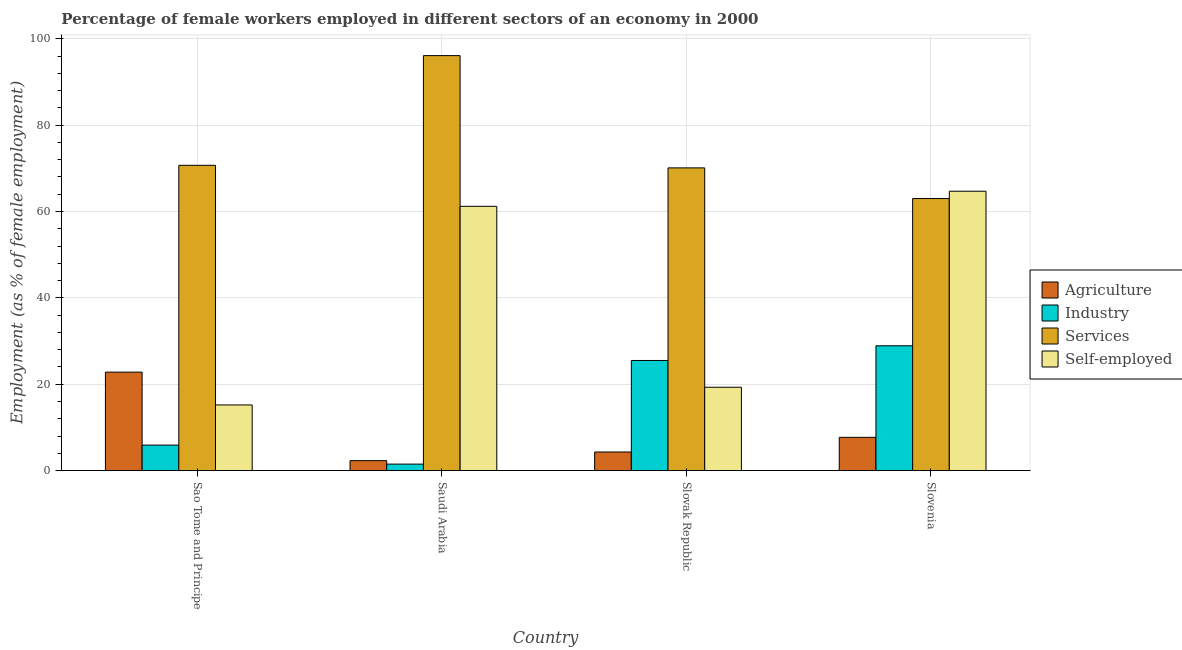How many different coloured bars are there?
Provide a short and direct response. 4. How many groups of bars are there?
Your answer should be compact. 4. Are the number of bars per tick equal to the number of legend labels?
Give a very brief answer. Yes. How many bars are there on the 3rd tick from the right?
Give a very brief answer. 4. What is the label of the 2nd group of bars from the left?
Provide a short and direct response. Saudi Arabia. In how many cases, is the number of bars for a given country not equal to the number of legend labels?
Offer a very short reply. 0. What is the percentage of female workers in agriculture in Sao Tome and Principe?
Provide a succinct answer. 22.8. Across all countries, what is the maximum percentage of female workers in agriculture?
Offer a terse response. 22.8. In which country was the percentage of female workers in agriculture maximum?
Your answer should be compact. Sao Tome and Principe. In which country was the percentage of female workers in agriculture minimum?
Your answer should be compact. Saudi Arabia. What is the total percentage of female workers in industry in the graph?
Provide a succinct answer. 61.8. What is the difference between the percentage of female workers in agriculture in Saudi Arabia and that in Slovenia?
Give a very brief answer. -5.4. What is the difference between the percentage of female workers in services in Slovak Republic and the percentage of female workers in industry in Saudi Arabia?
Give a very brief answer. 68.6. What is the average percentage of female workers in services per country?
Offer a very short reply. 74.97. What is the difference between the percentage of self employed female workers and percentage of female workers in agriculture in Slovenia?
Provide a short and direct response. 57. What is the ratio of the percentage of female workers in agriculture in Sao Tome and Principe to that in Slovenia?
Give a very brief answer. 2.96. Is the difference between the percentage of self employed female workers in Saudi Arabia and Slovenia greater than the difference between the percentage of female workers in industry in Saudi Arabia and Slovenia?
Give a very brief answer. Yes. What is the difference between the highest and the second highest percentage of female workers in industry?
Provide a short and direct response. 3.4. What is the difference between the highest and the lowest percentage of female workers in services?
Your answer should be compact. 33.1. What does the 3rd bar from the left in Slovak Republic represents?
Keep it short and to the point. Services. What does the 1st bar from the right in Slovenia represents?
Provide a succinct answer. Self-employed. Is it the case that in every country, the sum of the percentage of female workers in agriculture and percentage of female workers in industry is greater than the percentage of female workers in services?
Offer a very short reply. No. How many bars are there?
Offer a very short reply. 16. Are all the bars in the graph horizontal?
Your answer should be very brief. No. Where does the legend appear in the graph?
Your response must be concise. Center right. How are the legend labels stacked?
Give a very brief answer. Vertical. What is the title of the graph?
Offer a terse response. Percentage of female workers employed in different sectors of an economy in 2000. What is the label or title of the Y-axis?
Your response must be concise. Employment (as % of female employment). What is the Employment (as % of female employment) in Agriculture in Sao Tome and Principe?
Your response must be concise. 22.8. What is the Employment (as % of female employment) in Industry in Sao Tome and Principe?
Ensure brevity in your answer.  5.9. What is the Employment (as % of female employment) in Services in Sao Tome and Principe?
Offer a very short reply. 70.7. What is the Employment (as % of female employment) in Self-employed in Sao Tome and Principe?
Give a very brief answer. 15.2. What is the Employment (as % of female employment) in Agriculture in Saudi Arabia?
Offer a very short reply. 2.3. What is the Employment (as % of female employment) of Services in Saudi Arabia?
Your response must be concise. 96.1. What is the Employment (as % of female employment) of Self-employed in Saudi Arabia?
Provide a short and direct response. 61.2. What is the Employment (as % of female employment) of Agriculture in Slovak Republic?
Offer a very short reply. 4.3. What is the Employment (as % of female employment) of Industry in Slovak Republic?
Keep it short and to the point. 25.5. What is the Employment (as % of female employment) in Services in Slovak Republic?
Keep it short and to the point. 70.1. What is the Employment (as % of female employment) of Self-employed in Slovak Republic?
Provide a short and direct response. 19.3. What is the Employment (as % of female employment) in Agriculture in Slovenia?
Give a very brief answer. 7.7. What is the Employment (as % of female employment) in Industry in Slovenia?
Ensure brevity in your answer.  28.9. What is the Employment (as % of female employment) of Services in Slovenia?
Provide a short and direct response. 63. What is the Employment (as % of female employment) of Self-employed in Slovenia?
Your answer should be very brief. 64.7. Across all countries, what is the maximum Employment (as % of female employment) in Agriculture?
Ensure brevity in your answer.  22.8. Across all countries, what is the maximum Employment (as % of female employment) of Industry?
Ensure brevity in your answer.  28.9. Across all countries, what is the maximum Employment (as % of female employment) of Services?
Your answer should be very brief. 96.1. Across all countries, what is the maximum Employment (as % of female employment) of Self-employed?
Offer a very short reply. 64.7. Across all countries, what is the minimum Employment (as % of female employment) in Agriculture?
Your answer should be compact. 2.3. Across all countries, what is the minimum Employment (as % of female employment) in Industry?
Offer a very short reply. 1.5. Across all countries, what is the minimum Employment (as % of female employment) of Self-employed?
Your response must be concise. 15.2. What is the total Employment (as % of female employment) in Agriculture in the graph?
Your answer should be very brief. 37.1. What is the total Employment (as % of female employment) in Industry in the graph?
Ensure brevity in your answer.  61.8. What is the total Employment (as % of female employment) in Services in the graph?
Offer a terse response. 299.9. What is the total Employment (as % of female employment) in Self-employed in the graph?
Your answer should be compact. 160.4. What is the difference between the Employment (as % of female employment) in Agriculture in Sao Tome and Principe and that in Saudi Arabia?
Ensure brevity in your answer.  20.5. What is the difference between the Employment (as % of female employment) of Industry in Sao Tome and Principe and that in Saudi Arabia?
Ensure brevity in your answer.  4.4. What is the difference between the Employment (as % of female employment) in Services in Sao Tome and Principe and that in Saudi Arabia?
Keep it short and to the point. -25.4. What is the difference between the Employment (as % of female employment) of Self-employed in Sao Tome and Principe and that in Saudi Arabia?
Keep it short and to the point. -46. What is the difference between the Employment (as % of female employment) in Agriculture in Sao Tome and Principe and that in Slovak Republic?
Give a very brief answer. 18.5. What is the difference between the Employment (as % of female employment) of Industry in Sao Tome and Principe and that in Slovak Republic?
Ensure brevity in your answer.  -19.6. What is the difference between the Employment (as % of female employment) in Services in Sao Tome and Principe and that in Slovak Republic?
Make the answer very short. 0.6. What is the difference between the Employment (as % of female employment) of Agriculture in Sao Tome and Principe and that in Slovenia?
Ensure brevity in your answer.  15.1. What is the difference between the Employment (as % of female employment) of Services in Sao Tome and Principe and that in Slovenia?
Keep it short and to the point. 7.7. What is the difference between the Employment (as % of female employment) of Self-employed in Sao Tome and Principe and that in Slovenia?
Your answer should be compact. -49.5. What is the difference between the Employment (as % of female employment) in Agriculture in Saudi Arabia and that in Slovak Republic?
Give a very brief answer. -2. What is the difference between the Employment (as % of female employment) of Industry in Saudi Arabia and that in Slovak Republic?
Keep it short and to the point. -24. What is the difference between the Employment (as % of female employment) in Services in Saudi Arabia and that in Slovak Republic?
Your response must be concise. 26. What is the difference between the Employment (as % of female employment) in Self-employed in Saudi Arabia and that in Slovak Republic?
Offer a terse response. 41.9. What is the difference between the Employment (as % of female employment) in Industry in Saudi Arabia and that in Slovenia?
Your response must be concise. -27.4. What is the difference between the Employment (as % of female employment) in Services in Saudi Arabia and that in Slovenia?
Ensure brevity in your answer.  33.1. What is the difference between the Employment (as % of female employment) of Self-employed in Saudi Arabia and that in Slovenia?
Give a very brief answer. -3.5. What is the difference between the Employment (as % of female employment) in Agriculture in Slovak Republic and that in Slovenia?
Your answer should be compact. -3.4. What is the difference between the Employment (as % of female employment) in Industry in Slovak Republic and that in Slovenia?
Give a very brief answer. -3.4. What is the difference between the Employment (as % of female employment) of Services in Slovak Republic and that in Slovenia?
Offer a terse response. 7.1. What is the difference between the Employment (as % of female employment) in Self-employed in Slovak Republic and that in Slovenia?
Ensure brevity in your answer.  -45.4. What is the difference between the Employment (as % of female employment) in Agriculture in Sao Tome and Principe and the Employment (as % of female employment) in Industry in Saudi Arabia?
Your answer should be compact. 21.3. What is the difference between the Employment (as % of female employment) in Agriculture in Sao Tome and Principe and the Employment (as % of female employment) in Services in Saudi Arabia?
Make the answer very short. -73.3. What is the difference between the Employment (as % of female employment) of Agriculture in Sao Tome and Principe and the Employment (as % of female employment) of Self-employed in Saudi Arabia?
Provide a short and direct response. -38.4. What is the difference between the Employment (as % of female employment) in Industry in Sao Tome and Principe and the Employment (as % of female employment) in Services in Saudi Arabia?
Ensure brevity in your answer.  -90.2. What is the difference between the Employment (as % of female employment) of Industry in Sao Tome and Principe and the Employment (as % of female employment) of Self-employed in Saudi Arabia?
Make the answer very short. -55.3. What is the difference between the Employment (as % of female employment) of Agriculture in Sao Tome and Principe and the Employment (as % of female employment) of Industry in Slovak Republic?
Offer a very short reply. -2.7. What is the difference between the Employment (as % of female employment) of Agriculture in Sao Tome and Principe and the Employment (as % of female employment) of Services in Slovak Republic?
Give a very brief answer. -47.3. What is the difference between the Employment (as % of female employment) of Agriculture in Sao Tome and Principe and the Employment (as % of female employment) of Self-employed in Slovak Republic?
Offer a very short reply. 3.5. What is the difference between the Employment (as % of female employment) in Industry in Sao Tome and Principe and the Employment (as % of female employment) in Services in Slovak Republic?
Provide a succinct answer. -64.2. What is the difference between the Employment (as % of female employment) in Industry in Sao Tome and Principe and the Employment (as % of female employment) in Self-employed in Slovak Republic?
Ensure brevity in your answer.  -13.4. What is the difference between the Employment (as % of female employment) of Services in Sao Tome and Principe and the Employment (as % of female employment) of Self-employed in Slovak Republic?
Keep it short and to the point. 51.4. What is the difference between the Employment (as % of female employment) of Agriculture in Sao Tome and Principe and the Employment (as % of female employment) of Industry in Slovenia?
Your response must be concise. -6.1. What is the difference between the Employment (as % of female employment) of Agriculture in Sao Tome and Principe and the Employment (as % of female employment) of Services in Slovenia?
Provide a succinct answer. -40.2. What is the difference between the Employment (as % of female employment) of Agriculture in Sao Tome and Principe and the Employment (as % of female employment) of Self-employed in Slovenia?
Offer a very short reply. -41.9. What is the difference between the Employment (as % of female employment) of Industry in Sao Tome and Principe and the Employment (as % of female employment) of Services in Slovenia?
Your response must be concise. -57.1. What is the difference between the Employment (as % of female employment) in Industry in Sao Tome and Principe and the Employment (as % of female employment) in Self-employed in Slovenia?
Your answer should be compact. -58.8. What is the difference between the Employment (as % of female employment) of Agriculture in Saudi Arabia and the Employment (as % of female employment) of Industry in Slovak Republic?
Your answer should be very brief. -23.2. What is the difference between the Employment (as % of female employment) of Agriculture in Saudi Arabia and the Employment (as % of female employment) of Services in Slovak Republic?
Ensure brevity in your answer.  -67.8. What is the difference between the Employment (as % of female employment) of Agriculture in Saudi Arabia and the Employment (as % of female employment) of Self-employed in Slovak Republic?
Your answer should be very brief. -17. What is the difference between the Employment (as % of female employment) of Industry in Saudi Arabia and the Employment (as % of female employment) of Services in Slovak Republic?
Make the answer very short. -68.6. What is the difference between the Employment (as % of female employment) of Industry in Saudi Arabia and the Employment (as % of female employment) of Self-employed in Slovak Republic?
Ensure brevity in your answer.  -17.8. What is the difference between the Employment (as % of female employment) of Services in Saudi Arabia and the Employment (as % of female employment) of Self-employed in Slovak Republic?
Give a very brief answer. 76.8. What is the difference between the Employment (as % of female employment) of Agriculture in Saudi Arabia and the Employment (as % of female employment) of Industry in Slovenia?
Your answer should be compact. -26.6. What is the difference between the Employment (as % of female employment) in Agriculture in Saudi Arabia and the Employment (as % of female employment) in Services in Slovenia?
Provide a short and direct response. -60.7. What is the difference between the Employment (as % of female employment) of Agriculture in Saudi Arabia and the Employment (as % of female employment) of Self-employed in Slovenia?
Keep it short and to the point. -62.4. What is the difference between the Employment (as % of female employment) in Industry in Saudi Arabia and the Employment (as % of female employment) in Services in Slovenia?
Offer a very short reply. -61.5. What is the difference between the Employment (as % of female employment) of Industry in Saudi Arabia and the Employment (as % of female employment) of Self-employed in Slovenia?
Make the answer very short. -63.2. What is the difference between the Employment (as % of female employment) in Services in Saudi Arabia and the Employment (as % of female employment) in Self-employed in Slovenia?
Ensure brevity in your answer.  31.4. What is the difference between the Employment (as % of female employment) of Agriculture in Slovak Republic and the Employment (as % of female employment) of Industry in Slovenia?
Give a very brief answer. -24.6. What is the difference between the Employment (as % of female employment) of Agriculture in Slovak Republic and the Employment (as % of female employment) of Services in Slovenia?
Your answer should be very brief. -58.7. What is the difference between the Employment (as % of female employment) in Agriculture in Slovak Republic and the Employment (as % of female employment) in Self-employed in Slovenia?
Offer a terse response. -60.4. What is the difference between the Employment (as % of female employment) of Industry in Slovak Republic and the Employment (as % of female employment) of Services in Slovenia?
Provide a succinct answer. -37.5. What is the difference between the Employment (as % of female employment) in Industry in Slovak Republic and the Employment (as % of female employment) in Self-employed in Slovenia?
Your answer should be very brief. -39.2. What is the average Employment (as % of female employment) in Agriculture per country?
Your answer should be compact. 9.28. What is the average Employment (as % of female employment) in Industry per country?
Your answer should be compact. 15.45. What is the average Employment (as % of female employment) in Services per country?
Provide a succinct answer. 74.97. What is the average Employment (as % of female employment) in Self-employed per country?
Your answer should be compact. 40.1. What is the difference between the Employment (as % of female employment) of Agriculture and Employment (as % of female employment) of Services in Sao Tome and Principe?
Provide a succinct answer. -47.9. What is the difference between the Employment (as % of female employment) of Agriculture and Employment (as % of female employment) of Self-employed in Sao Tome and Principe?
Your response must be concise. 7.6. What is the difference between the Employment (as % of female employment) in Industry and Employment (as % of female employment) in Services in Sao Tome and Principe?
Offer a very short reply. -64.8. What is the difference between the Employment (as % of female employment) of Industry and Employment (as % of female employment) of Self-employed in Sao Tome and Principe?
Ensure brevity in your answer.  -9.3. What is the difference between the Employment (as % of female employment) of Services and Employment (as % of female employment) of Self-employed in Sao Tome and Principe?
Keep it short and to the point. 55.5. What is the difference between the Employment (as % of female employment) of Agriculture and Employment (as % of female employment) of Industry in Saudi Arabia?
Provide a succinct answer. 0.8. What is the difference between the Employment (as % of female employment) in Agriculture and Employment (as % of female employment) in Services in Saudi Arabia?
Give a very brief answer. -93.8. What is the difference between the Employment (as % of female employment) in Agriculture and Employment (as % of female employment) in Self-employed in Saudi Arabia?
Offer a terse response. -58.9. What is the difference between the Employment (as % of female employment) in Industry and Employment (as % of female employment) in Services in Saudi Arabia?
Offer a very short reply. -94.6. What is the difference between the Employment (as % of female employment) of Industry and Employment (as % of female employment) of Self-employed in Saudi Arabia?
Make the answer very short. -59.7. What is the difference between the Employment (as % of female employment) of Services and Employment (as % of female employment) of Self-employed in Saudi Arabia?
Your answer should be very brief. 34.9. What is the difference between the Employment (as % of female employment) of Agriculture and Employment (as % of female employment) of Industry in Slovak Republic?
Your answer should be compact. -21.2. What is the difference between the Employment (as % of female employment) in Agriculture and Employment (as % of female employment) in Services in Slovak Republic?
Give a very brief answer. -65.8. What is the difference between the Employment (as % of female employment) of Industry and Employment (as % of female employment) of Services in Slovak Republic?
Give a very brief answer. -44.6. What is the difference between the Employment (as % of female employment) of Industry and Employment (as % of female employment) of Self-employed in Slovak Republic?
Offer a very short reply. 6.2. What is the difference between the Employment (as % of female employment) of Services and Employment (as % of female employment) of Self-employed in Slovak Republic?
Offer a terse response. 50.8. What is the difference between the Employment (as % of female employment) in Agriculture and Employment (as % of female employment) in Industry in Slovenia?
Offer a very short reply. -21.2. What is the difference between the Employment (as % of female employment) of Agriculture and Employment (as % of female employment) of Services in Slovenia?
Your answer should be very brief. -55.3. What is the difference between the Employment (as % of female employment) in Agriculture and Employment (as % of female employment) in Self-employed in Slovenia?
Make the answer very short. -57. What is the difference between the Employment (as % of female employment) of Industry and Employment (as % of female employment) of Services in Slovenia?
Make the answer very short. -34.1. What is the difference between the Employment (as % of female employment) of Industry and Employment (as % of female employment) of Self-employed in Slovenia?
Your response must be concise. -35.8. What is the difference between the Employment (as % of female employment) in Services and Employment (as % of female employment) in Self-employed in Slovenia?
Offer a very short reply. -1.7. What is the ratio of the Employment (as % of female employment) in Agriculture in Sao Tome and Principe to that in Saudi Arabia?
Ensure brevity in your answer.  9.91. What is the ratio of the Employment (as % of female employment) of Industry in Sao Tome and Principe to that in Saudi Arabia?
Your response must be concise. 3.93. What is the ratio of the Employment (as % of female employment) of Services in Sao Tome and Principe to that in Saudi Arabia?
Provide a short and direct response. 0.74. What is the ratio of the Employment (as % of female employment) in Self-employed in Sao Tome and Principe to that in Saudi Arabia?
Your response must be concise. 0.25. What is the ratio of the Employment (as % of female employment) in Agriculture in Sao Tome and Principe to that in Slovak Republic?
Provide a succinct answer. 5.3. What is the ratio of the Employment (as % of female employment) in Industry in Sao Tome and Principe to that in Slovak Republic?
Give a very brief answer. 0.23. What is the ratio of the Employment (as % of female employment) of Services in Sao Tome and Principe to that in Slovak Republic?
Keep it short and to the point. 1.01. What is the ratio of the Employment (as % of female employment) in Self-employed in Sao Tome and Principe to that in Slovak Republic?
Provide a succinct answer. 0.79. What is the ratio of the Employment (as % of female employment) in Agriculture in Sao Tome and Principe to that in Slovenia?
Make the answer very short. 2.96. What is the ratio of the Employment (as % of female employment) in Industry in Sao Tome and Principe to that in Slovenia?
Your answer should be very brief. 0.2. What is the ratio of the Employment (as % of female employment) of Services in Sao Tome and Principe to that in Slovenia?
Provide a short and direct response. 1.12. What is the ratio of the Employment (as % of female employment) in Self-employed in Sao Tome and Principe to that in Slovenia?
Your answer should be very brief. 0.23. What is the ratio of the Employment (as % of female employment) of Agriculture in Saudi Arabia to that in Slovak Republic?
Offer a very short reply. 0.53. What is the ratio of the Employment (as % of female employment) of Industry in Saudi Arabia to that in Slovak Republic?
Your answer should be compact. 0.06. What is the ratio of the Employment (as % of female employment) in Services in Saudi Arabia to that in Slovak Republic?
Provide a succinct answer. 1.37. What is the ratio of the Employment (as % of female employment) of Self-employed in Saudi Arabia to that in Slovak Republic?
Your response must be concise. 3.17. What is the ratio of the Employment (as % of female employment) of Agriculture in Saudi Arabia to that in Slovenia?
Your response must be concise. 0.3. What is the ratio of the Employment (as % of female employment) in Industry in Saudi Arabia to that in Slovenia?
Make the answer very short. 0.05. What is the ratio of the Employment (as % of female employment) in Services in Saudi Arabia to that in Slovenia?
Provide a short and direct response. 1.53. What is the ratio of the Employment (as % of female employment) of Self-employed in Saudi Arabia to that in Slovenia?
Give a very brief answer. 0.95. What is the ratio of the Employment (as % of female employment) in Agriculture in Slovak Republic to that in Slovenia?
Your response must be concise. 0.56. What is the ratio of the Employment (as % of female employment) in Industry in Slovak Republic to that in Slovenia?
Keep it short and to the point. 0.88. What is the ratio of the Employment (as % of female employment) in Services in Slovak Republic to that in Slovenia?
Make the answer very short. 1.11. What is the ratio of the Employment (as % of female employment) of Self-employed in Slovak Republic to that in Slovenia?
Offer a very short reply. 0.3. What is the difference between the highest and the second highest Employment (as % of female employment) in Agriculture?
Keep it short and to the point. 15.1. What is the difference between the highest and the second highest Employment (as % of female employment) of Services?
Your answer should be compact. 25.4. What is the difference between the highest and the second highest Employment (as % of female employment) of Self-employed?
Your answer should be very brief. 3.5. What is the difference between the highest and the lowest Employment (as % of female employment) of Agriculture?
Give a very brief answer. 20.5. What is the difference between the highest and the lowest Employment (as % of female employment) of Industry?
Provide a short and direct response. 27.4. What is the difference between the highest and the lowest Employment (as % of female employment) of Services?
Provide a succinct answer. 33.1. What is the difference between the highest and the lowest Employment (as % of female employment) of Self-employed?
Ensure brevity in your answer.  49.5. 